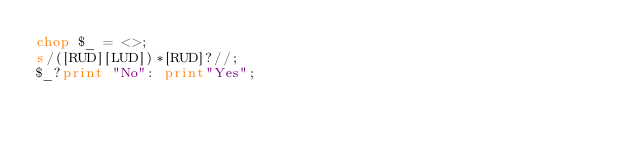<code> <loc_0><loc_0><loc_500><loc_500><_Perl_>chop $_ = <>;
s/([RUD][LUD])*[RUD]?//;
$_?print "No": print"Yes";
</code> 